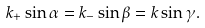<formula> <loc_0><loc_0><loc_500><loc_500>k _ { + } \sin \alpha = k _ { - } \sin \beta = k \sin \gamma .</formula> 